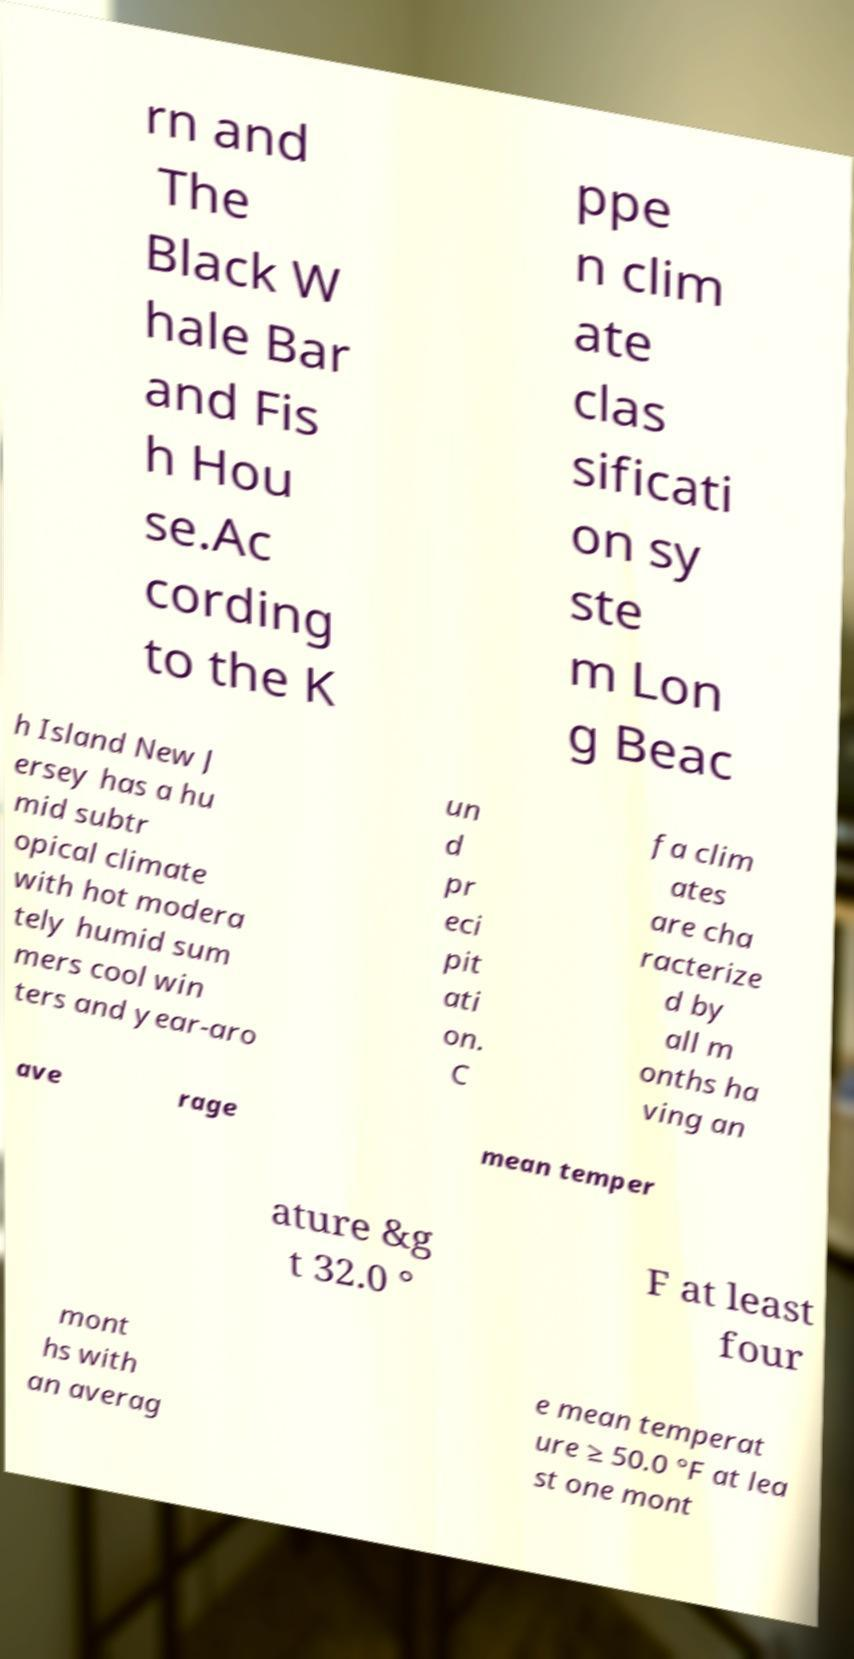There's text embedded in this image that I need extracted. Can you transcribe it verbatim? rn and The Black W hale Bar and Fis h Hou se.Ac cording to the K ppe n clim ate clas sificati on sy ste m Lon g Beac h Island New J ersey has a hu mid subtr opical climate with hot modera tely humid sum mers cool win ters and year-aro un d pr eci pit ati on. C fa clim ates are cha racterize d by all m onths ha ving an ave rage mean temper ature &g t 32.0 ° F at least four mont hs with an averag e mean temperat ure ≥ 50.0 °F at lea st one mont 